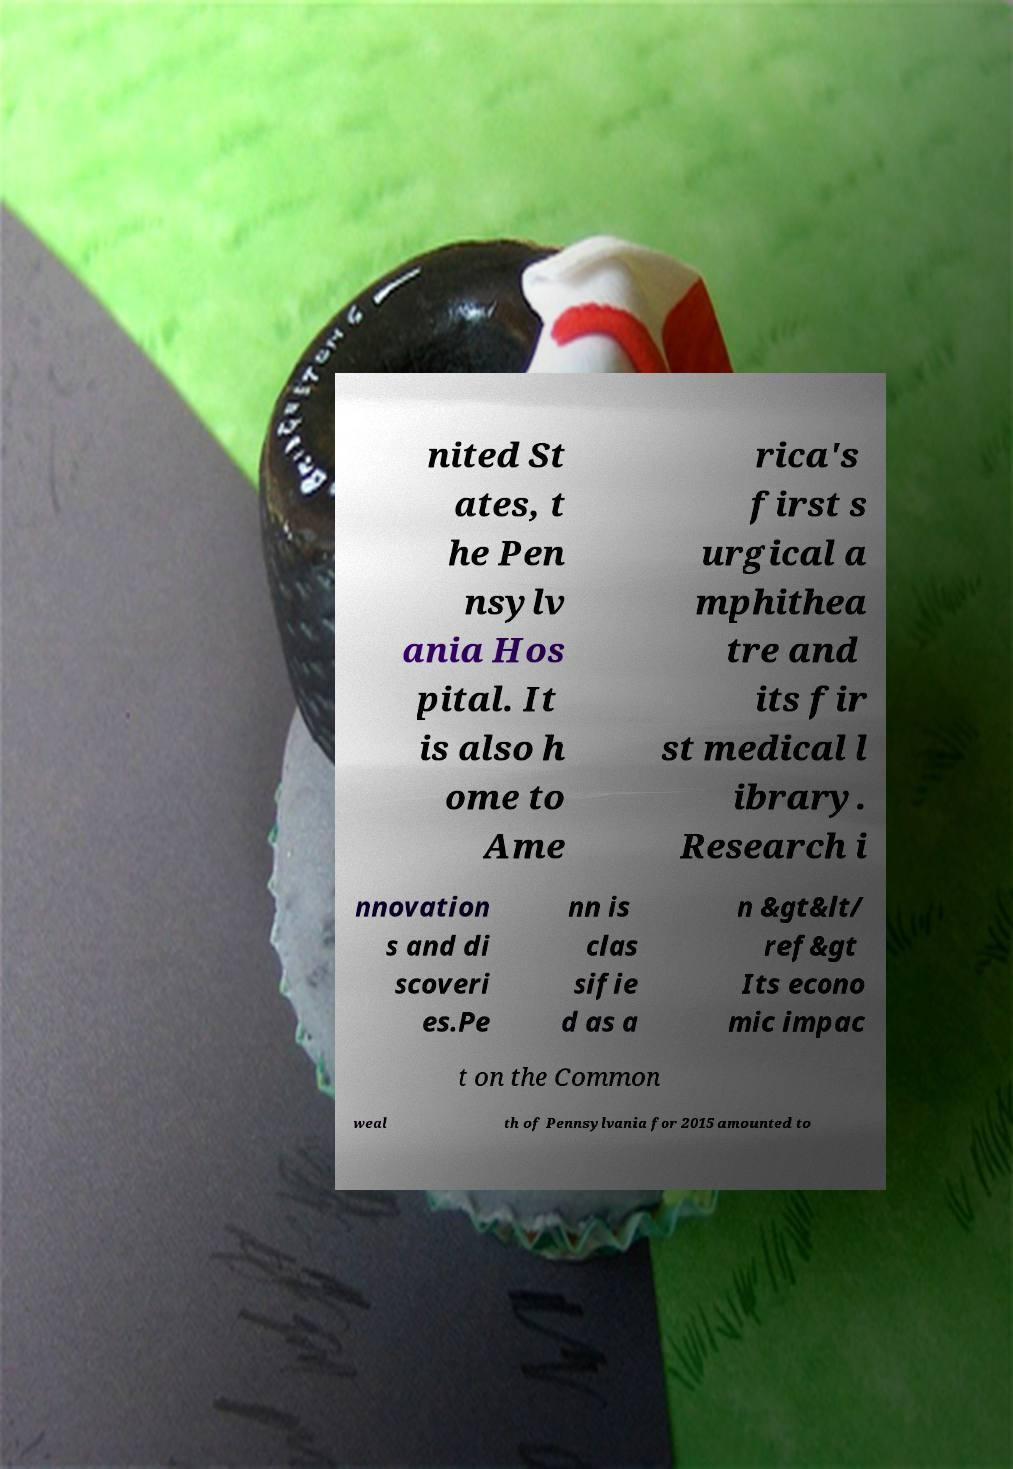Please identify and transcribe the text found in this image. nited St ates, t he Pen nsylv ania Hos pital. It is also h ome to Ame rica's first s urgical a mphithea tre and its fir st medical l ibrary. Research i nnovation s and di scoveri es.Pe nn is clas sifie d as a n &gt&lt/ ref&gt Its econo mic impac t on the Common weal th of Pennsylvania for 2015 amounted to 